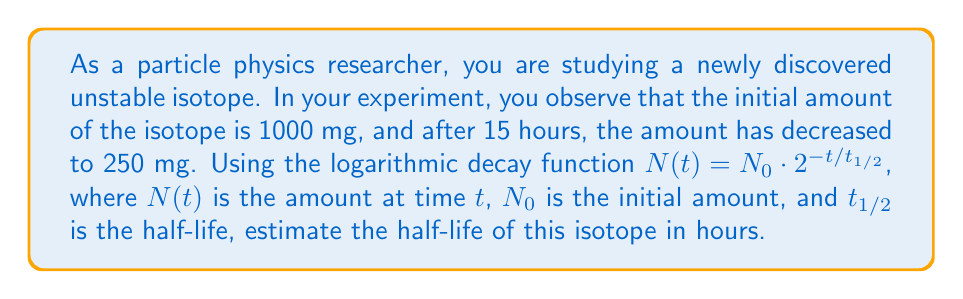Solve this math problem. To solve this problem, we'll use the given logarithmic decay function and the information provided:

1) The decay function is: $N(t) = N_0 \cdot 2^{-t/t_{1/2}}$

2) We know:
   $N_0 = 1000$ mg (initial amount)
   $N(15) = 250$ mg (amount after 15 hours)
   $t = 15$ hours

3) Let's substitute these values into the equation:

   $250 = 1000 \cdot 2^{-15/t_{1/2}}$

4) Divide both sides by 1000:

   $\frac{1}{4} = 2^{-15/t_{1/2}}$

5) Take the logarithm (base 2) of both sides:

   $\log_2(\frac{1}{4}) = -\frac{15}{t_{1/2}}$

6) Simplify the left side:

   $-2 = -\frac{15}{t_{1/2}}$

7) Multiply both sides by $-t_{1/2}$:

   $2t_{1/2} = 15$

8) Solve for $t_{1/2}$:

   $t_{1/2} = \frac{15}{2} = 7.5$

Therefore, the estimated half-life of the isotope is 7.5 hours.
Answer: $t_{1/2} = 7.5$ hours 